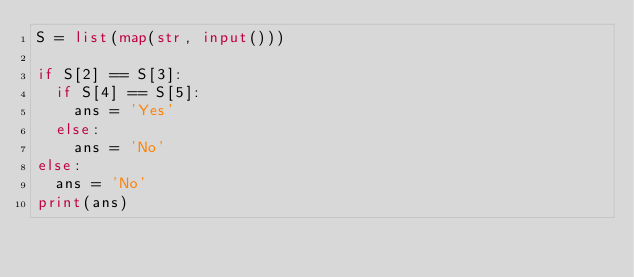Convert code to text. <code><loc_0><loc_0><loc_500><loc_500><_Python_>S = list(map(str, input()))

if S[2] == S[3]:
  if S[4] == S[5]:
    ans = 'Yes'
  else:
    ans = 'No'
else:
  ans = 'No'
print(ans)</code> 